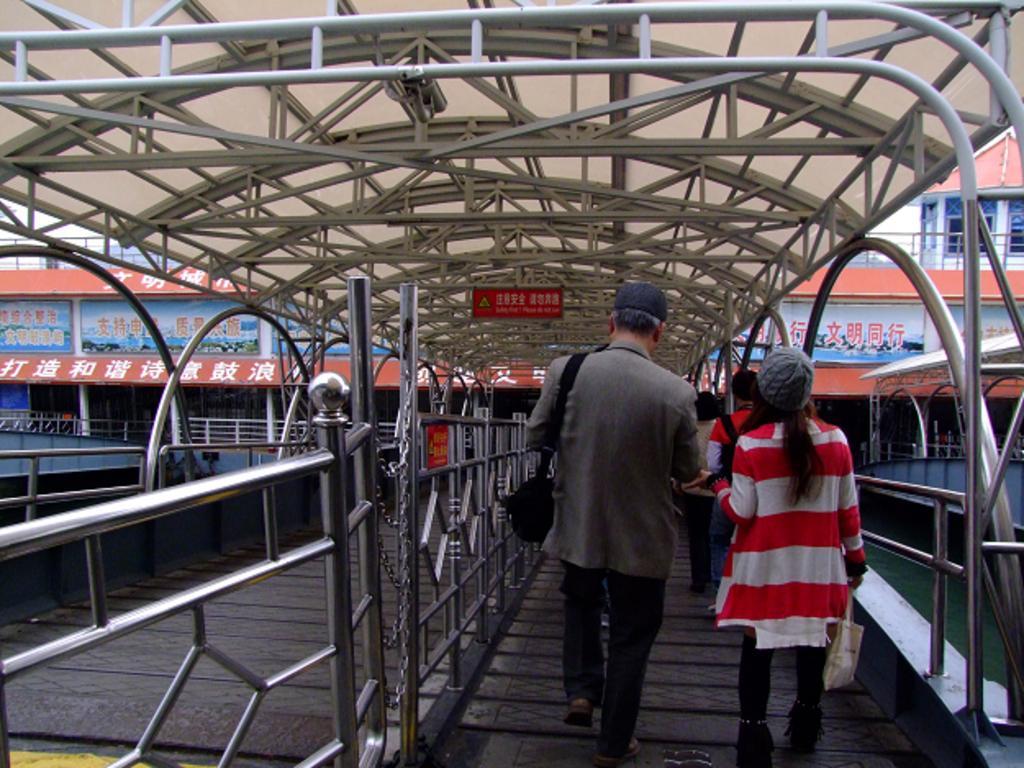Can you describe this image briefly? In this picture we can see beams, railings, chains, people, objects and red board. We can see a man wearing a cap and carrying a bag. We can see a woman wearing a cap and holding a carry bag. On the right side of the picture we can see a boat and water. 